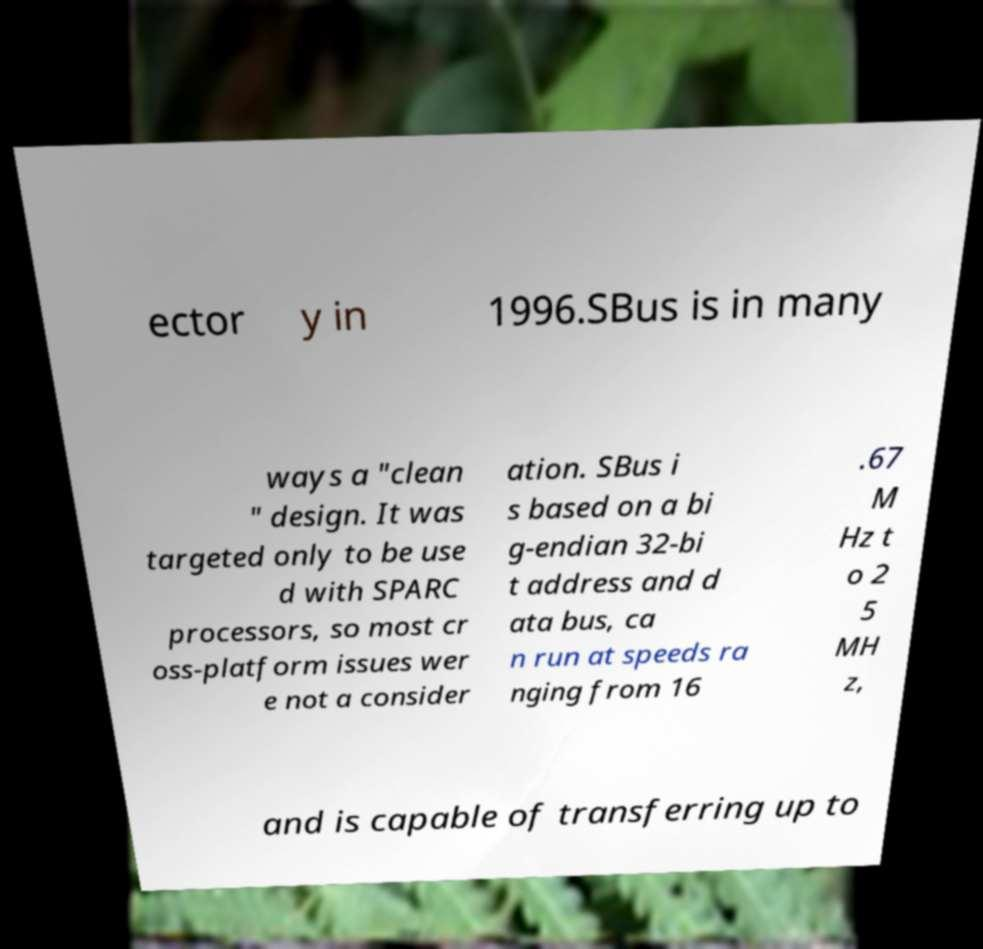Can you read and provide the text displayed in the image?This photo seems to have some interesting text. Can you extract and type it out for me? ector y in 1996.SBus is in many ways a "clean " design. It was targeted only to be use d with SPARC processors, so most cr oss-platform issues wer e not a consider ation. SBus i s based on a bi g-endian 32-bi t address and d ata bus, ca n run at speeds ra nging from 16 .67 M Hz t o 2 5 MH z, and is capable of transferring up to 